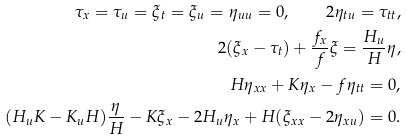Convert formula to latex. <formula><loc_0><loc_0><loc_500><loc_500>\tau _ { x } = \tau _ { u } = \xi _ { t } = \xi _ { u } = \eta _ { u u } = 0 , \quad 2 \eta _ { t u } = \tau _ { t t } , \\ 2 ( \xi _ { x } - \tau _ { t } ) + \frac { f _ { x } } { f } \xi = \frac { H _ { u } } { H } \eta , \\ H \eta _ { x x } + K \eta _ { x } - f \eta _ { t t } = 0 , \\ ( H _ { u } K - K _ { u } H ) \frac { \eta } { H } - K \xi _ { x } - 2 H _ { u } \eta _ { x } + H ( \xi _ { x x } - 2 \eta _ { x u } ) = 0 .</formula> 